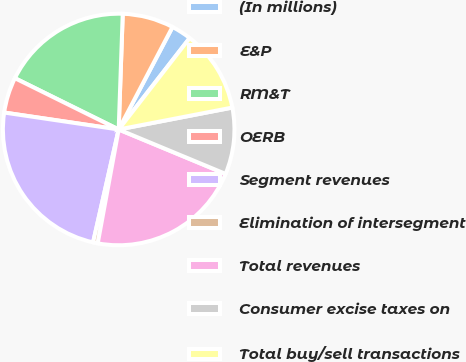Convert chart to OTSL. <chart><loc_0><loc_0><loc_500><loc_500><pie_chart><fcel>(In millions)<fcel>E&P<fcel>RM&T<fcel>OERB<fcel>Segment revenues<fcel>Elimination of intersegment<fcel>Total revenues<fcel>Consumer excise taxes on<fcel>Total buy/sell transactions<nl><fcel>2.81%<fcel>7.14%<fcel>18.25%<fcel>4.97%<fcel>23.79%<fcel>0.65%<fcel>21.63%<fcel>9.3%<fcel>11.46%<nl></chart> 